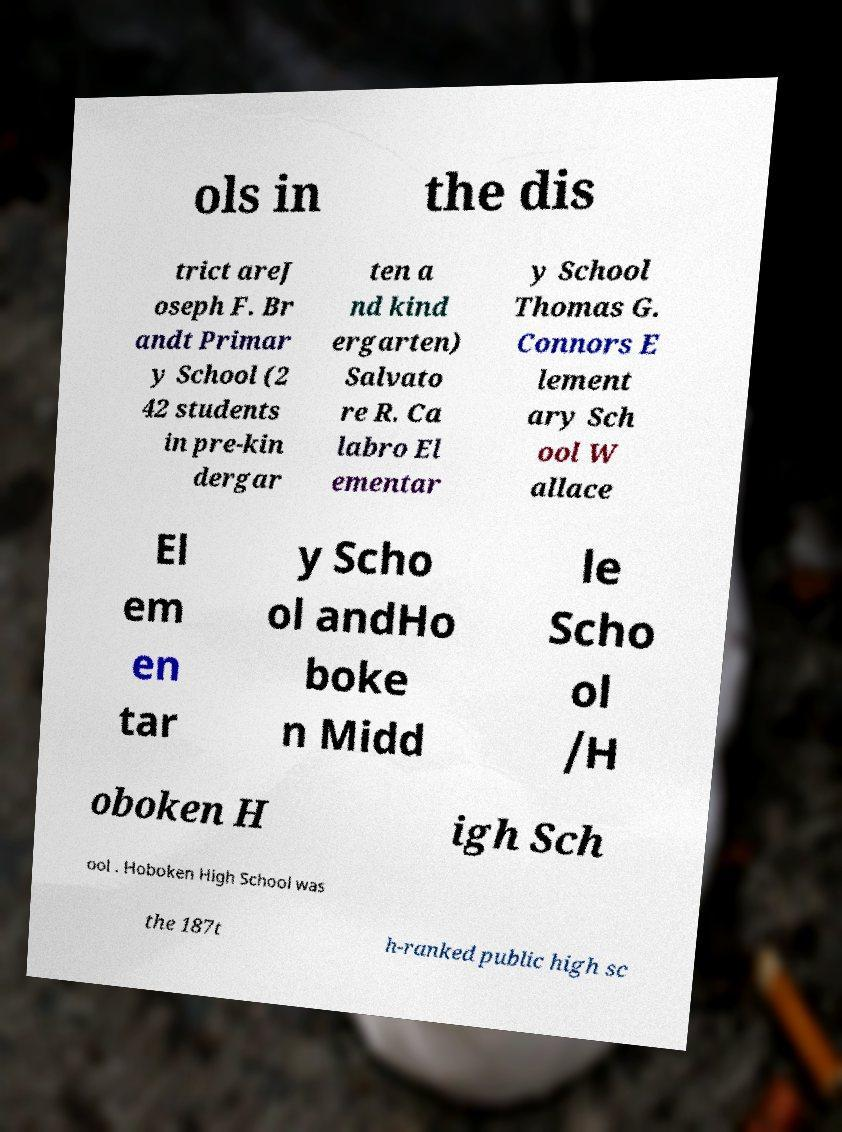Please identify and transcribe the text found in this image. ols in the dis trict areJ oseph F. Br andt Primar y School (2 42 students in pre-kin dergar ten a nd kind ergarten) Salvato re R. Ca labro El ementar y School Thomas G. Connors E lement ary Sch ool W allace El em en tar y Scho ol andHo boke n Midd le Scho ol /H oboken H igh Sch ool . Hoboken High School was the 187t h-ranked public high sc 